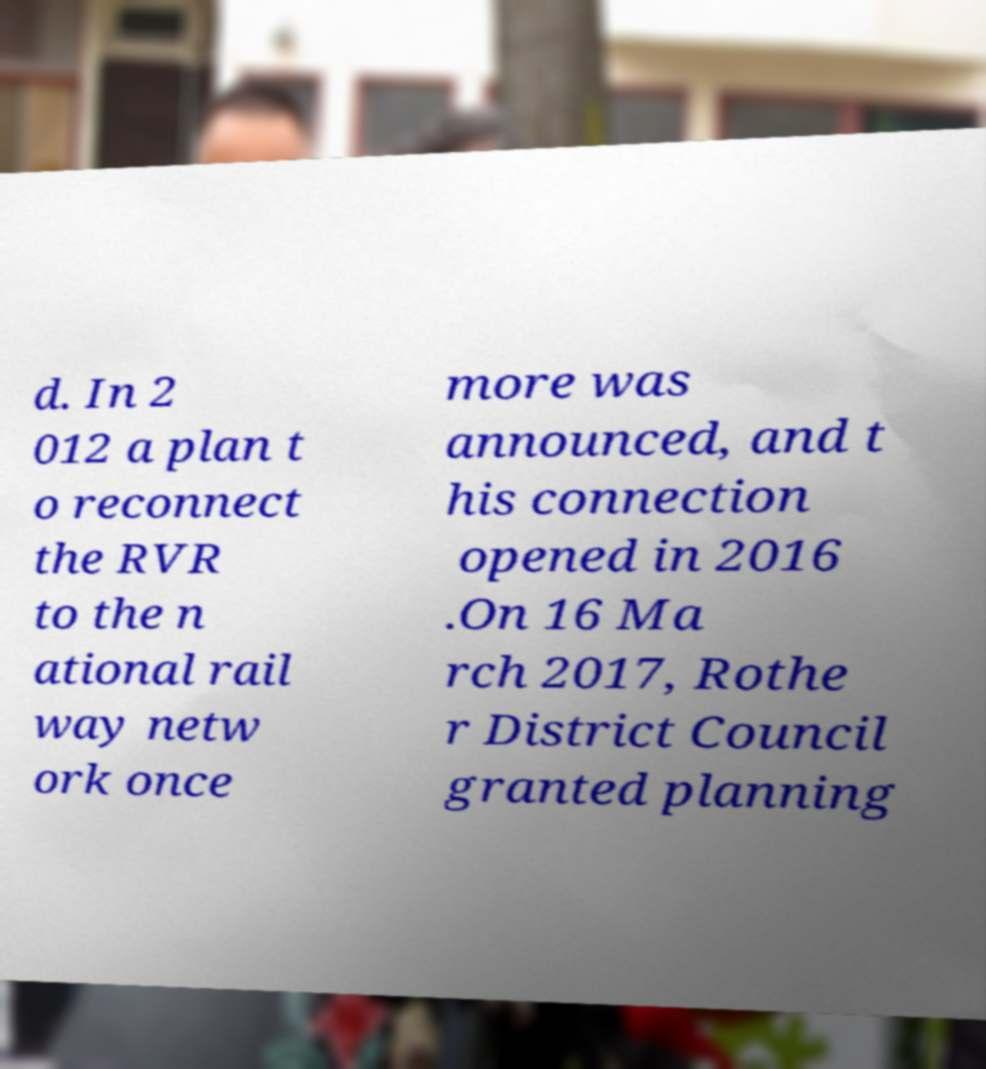Please read and relay the text visible in this image. What does it say? d. In 2 012 a plan t o reconnect the RVR to the n ational rail way netw ork once more was announced, and t his connection opened in 2016 .On 16 Ma rch 2017, Rothe r District Council granted planning 